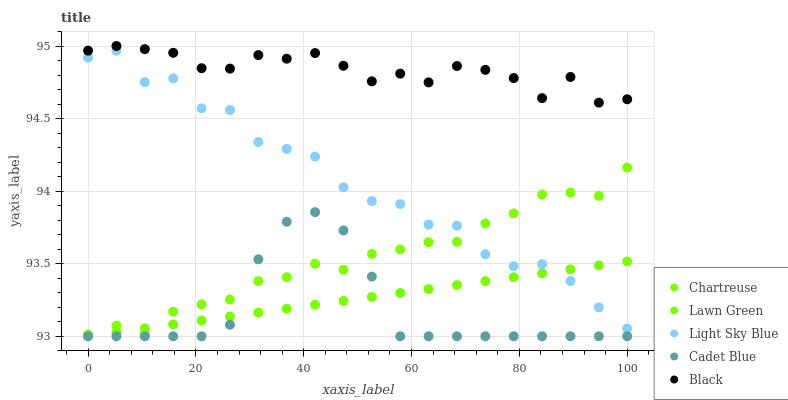Does Cadet Blue have the minimum area under the curve?
Answer yes or no. Yes. Does Black have the maximum area under the curve?
Answer yes or no. Yes. Does Lawn Green have the minimum area under the curve?
Answer yes or no. No. Does Lawn Green have the maximum area under the curve?
Answer yes or no. No. Is Lawn Green the smoothest?
Answer yes or no. Yes. Is Light Sky Blue the roughest?
Answer yes or no. Yes. Is Chartreuse the smoothest?
Answer yes or no. No. Is Chartreuse the roughest?
Answer yes or no. No. Does Cadet Blue have the lowest value?
Answer yes or no. Yes. Does Chartreuse have the lowest value?
Answer yes or no. No. Does Black have the highest value?
Answer yes or no. Yes. Does Chartreuse have the highest value?
Answer yes or no. No. Is Light Sky Blue less than Black?
Answer yes or no. Yes. Is Black greater than Light Sky Blue?
Answer yes or no. Yes. Does Cadet Blue intersect Chartreuse?
Answer yes or no. Yes. Is Cadet Blue less than Chartreuse?
Answer yes or no. No. Is Cadet Blue greater than Chartreuse?
Answer yes or no. No. Does Light Sky Blue intersect Black?
Answer yes or no. No. 